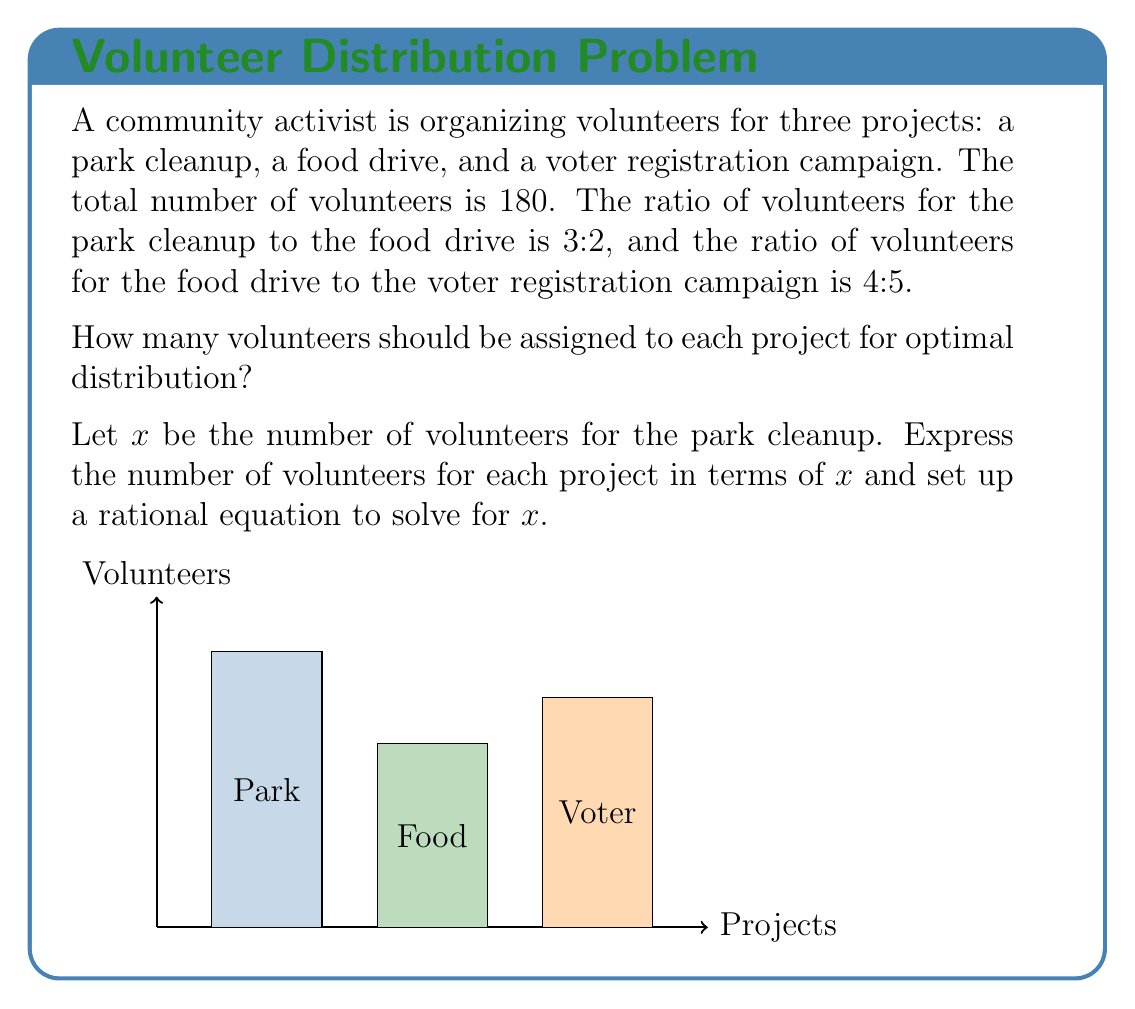Show me your answer to this math problem. Let's solve this step-by-step:

1) Let x be the number of volunteers for the park cleanup.

2) Given the ratios, we can express the other projects in terms of x:
   - Park cleanup: x
   - Food drive: $\frac{2}{3}x$ (because 3:2 ratio with park cleanup)
   - Voter registration: $\frac{5}{4} \cdot \frac{2}{3}x = \frac{5}{6}x$ (because 4:5 ratio with food drive)

3) The total number of volunteers is 180, so we can set up the equation:

   $$x + \frac{2}{3}x + \frac{5}{6}x = 180$$

4) Simplify by finding a common denominator:

   $$\frac{6}{6}x + \frac{4}{6}x + \frac{5}{6}x = 180$$

5) Add the fractions:

   $$\frac{15}{6}x = 180$$

6) Multiply both sides by 6:

   $$15x = 1080$$

7) Divide both sides by 15:

   $$x = 72$$

8) Now we can calculate the other values:
   - Park cleanup: 72 volunteers
   - Food drive: $\frac{2}{3} \cdot 72 = 48$ volunteers
   - Voter registration: $\frac{5}{6} \cdot 72 = 60$ volunteers

9) Verify: 72 + 48 + 60 = 180, which matches the total number of volunteers.
Answer: Park cleanup: 72, Food drive: 48, Voter registration: 60 